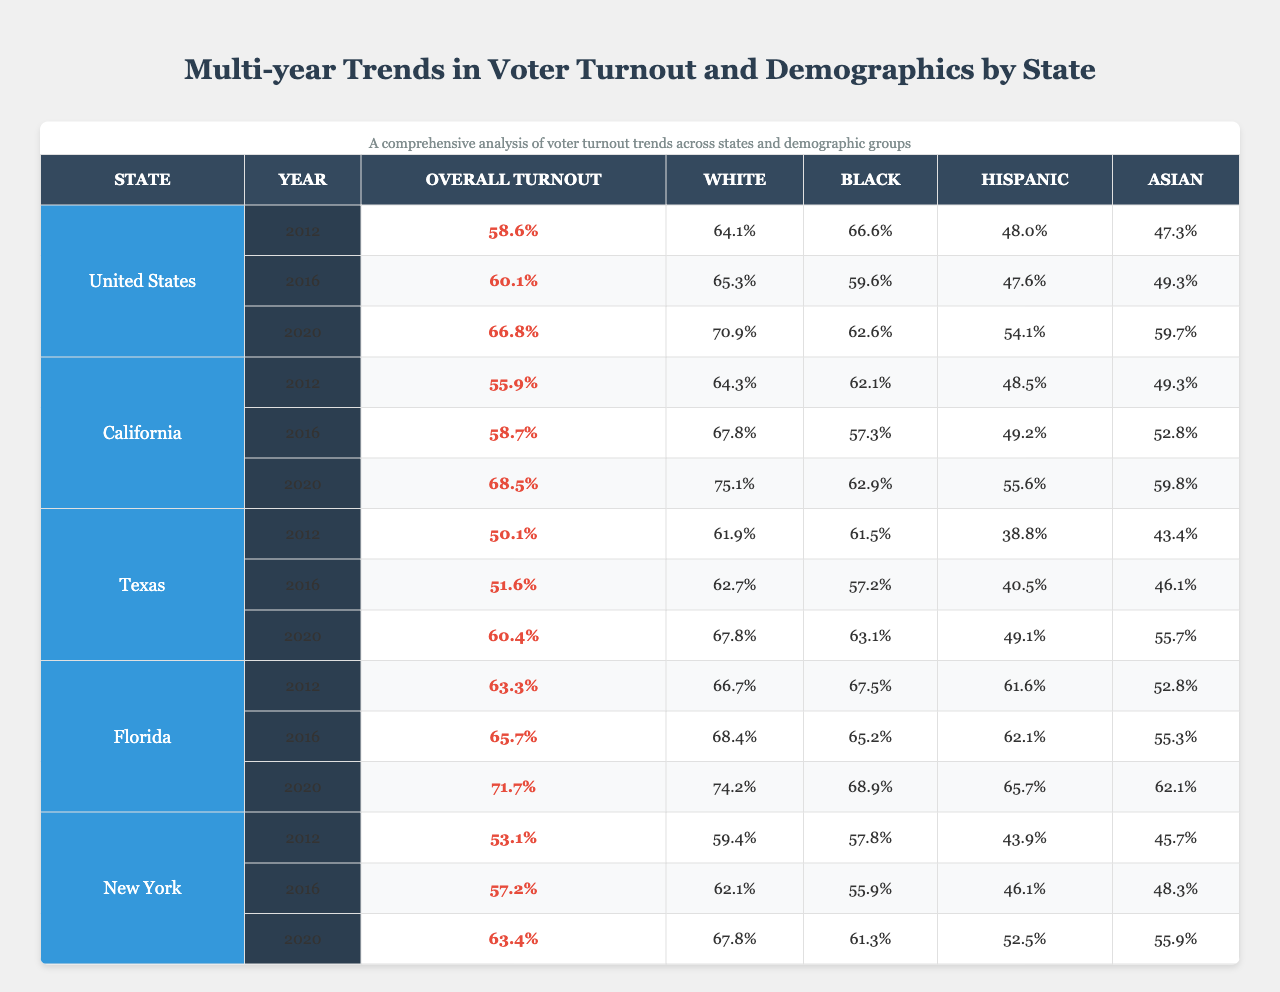What was the overall voter turnout in the United States in 2020? The table shows that the overall voter turnout in the United States for 2020 is listed as 66.8%.
Answer: 66.8% Which state had the highest overall turnout in 2020? By comparing the overall turnout values for 2020 across all states, California had the highest value at 68.5%.
Answer: California In which year did the Hispanic voter turnout see the largest increase in Texas? Looking at the Hispanic voter turnout percentages in Texas, it increased from 38.8% in 2012 to 49.1% in 2020, showing the largest increase over these years.
Answer: 2020 What is the difference in overall voter turnout between Florida in 2012 and 2020? The overall turnout in Florida in 2012 was 63.3%, and in 2020 it was 71.7%. The difference is calculated as 71.7% - 63.3% = 8.4%.
Answer: 8.4% Did the Black voter turnout in California decrease from 2012 to 2016? In California, Black voter turnout was 62.1% in 2012 and decreased to 57.3% in 2016, indicating a decrease.
Answer: Yes What is the average percentage of Asian voter turnout across all states for 2016? The Asian voter turnout percentages for 2016 are: California (52.8%), Texas (46.1%), Florida (55.3%), and New York (48.3%). The average is (52.8 + 46.1 + 55.3 + 48.3) / 4 = 50.625%.
Answer: 50.625% Which demographic in the United States had the highest turnout in 2020? The turnout percentages for 2020 show that the White demographic had the highest turnout at 70.9%, compared to Black (62.6%), Hispanic (54.1%), and Asian (59.7%).
Answer: White For California, how much did the White voter turnout increase from 2012 to 2020? The White voter turnout in California increased from 64.3% in 2012 to 75.1% in 2020. The increase is 75.1% - 64.3% = 10.8%.
Answer: 10.8% True or False: The Asian voter turnout was higher than the Hispanic voter turnout in Texas for all three years. Analyzing the data, in 2012 and 2016, Hispanic turnout (38.8% and 40.5%) was lower than Asian turnout (43.4% and 46.1%), but in 2020, Hispanic turnout (49.1%) surpassed Asian turnout (55.7%). This makes the statement false.
Answer: False What state consistently had the lowest overall voter turnout across all three surveyed years? The analysis shows that Texas had the lowest overall turnout in 2012 (50.1%), 2016 (51.6%), and 2020 (60.4%) compared to the other states listed.
Answer: Texas What was the change in turnout for the Black demographic in Florida from 2016 to 2020? The Black voter turnout in Florida rose from 65.2% in 2016 to 68.9% in 2020, showing an increase of 3.7%.
Answer: 3.7% 